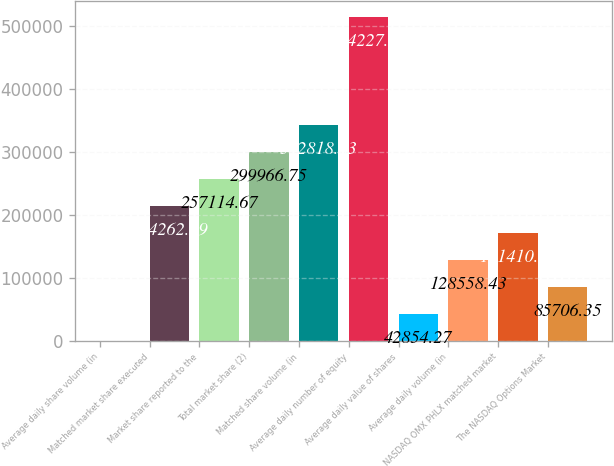<chart> <loc_0><loc_0><loc_500><loc_500><bar_chart><fcel>Average daily share volume (in<fcel>Matched market share executed<fcel>Market share reported to the<fcel>Total market share (2)<fcel>Matched share volume (in<fcel>Average daily number of equity<fcel>Average daily value of shares<fcel>Average daily volume (in<fcel>NASDAQ OMX PHLX matched market<fcel>The NASDAQ Options Market<nl><fcel>2.19<fcel>214263<fcel>257115<fcel>299967<fcel>342819<fcel>514227<fcel>42854.3<fcel>128558<fcel>171411<fcel>85706.4<nl></chart> 